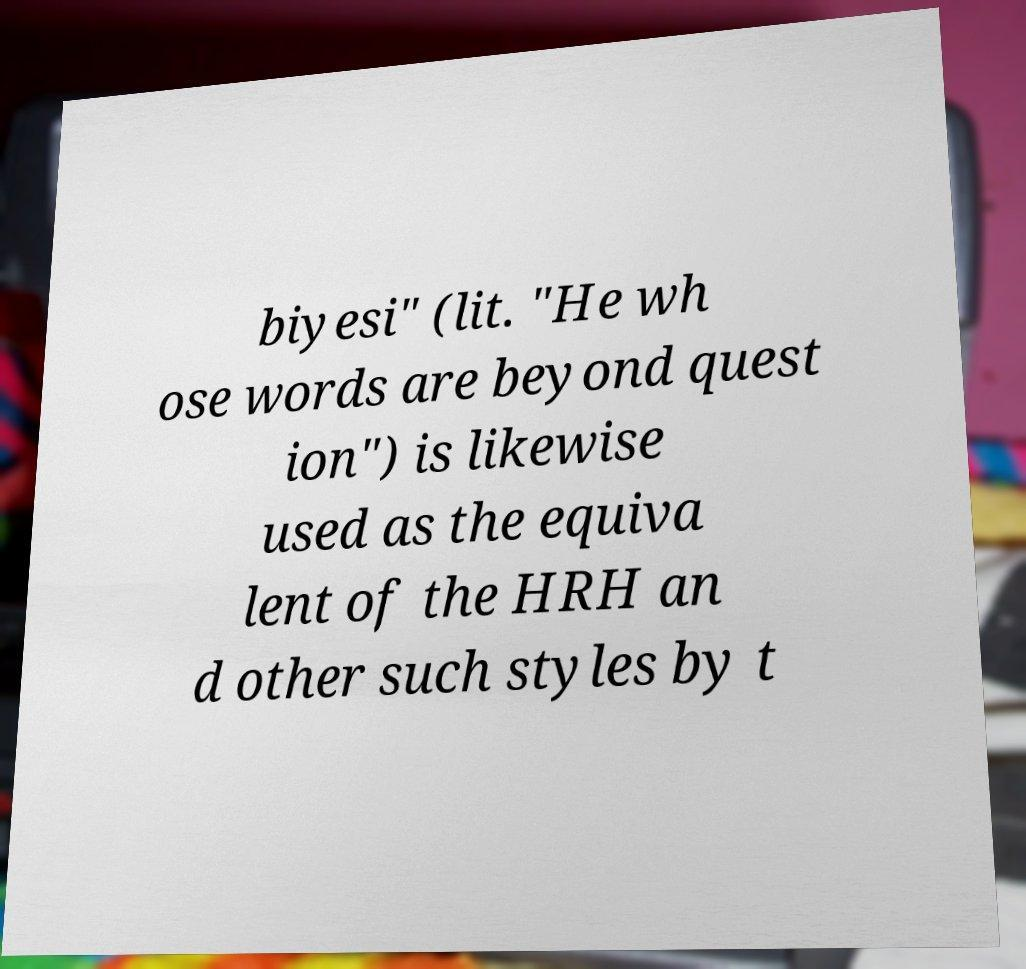There's text embedded in this image that I need extracted. Can you transcribe it verbatim? biyesi" (lit. "He wh ose words are beyond quest ion") is likewise used as the equiva lent of the HRH an d other such styles by t 